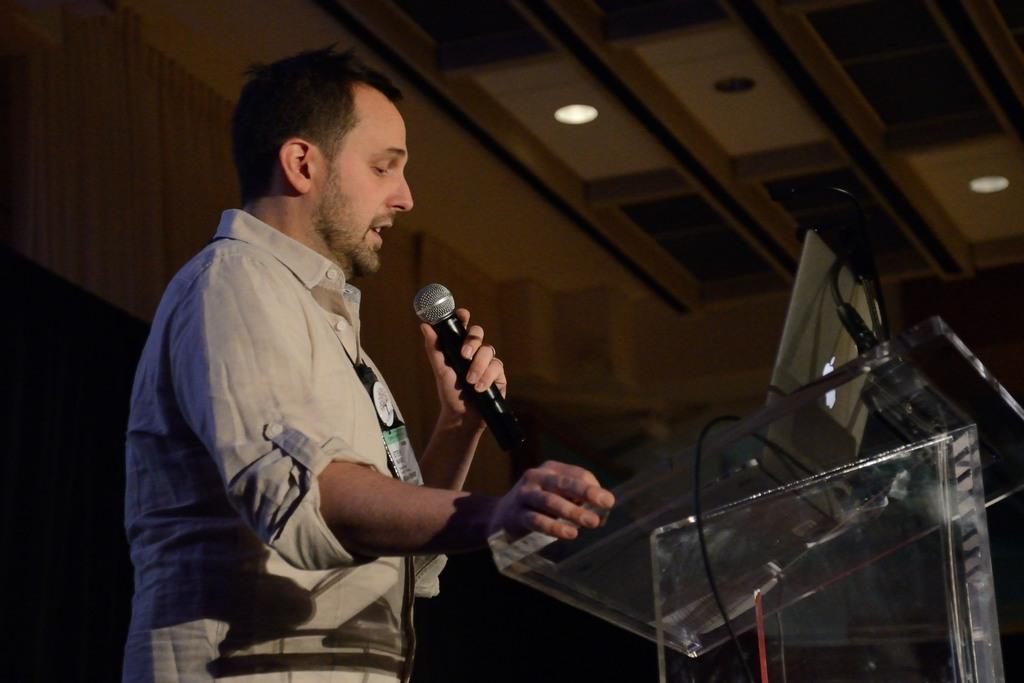Who is the main subject in the image? There is a man in the image. Where is the man located in the image? The man is on the left side of the image. What is the man holding in his hand? The man is holding a mic in his hand. What is in front of the man? There is a desk in front of the man. What might the man be doing in the image? The man appears to be addressing an audience. How many times does the man laugh in the image? There is no indication of the man laughing in the image. 